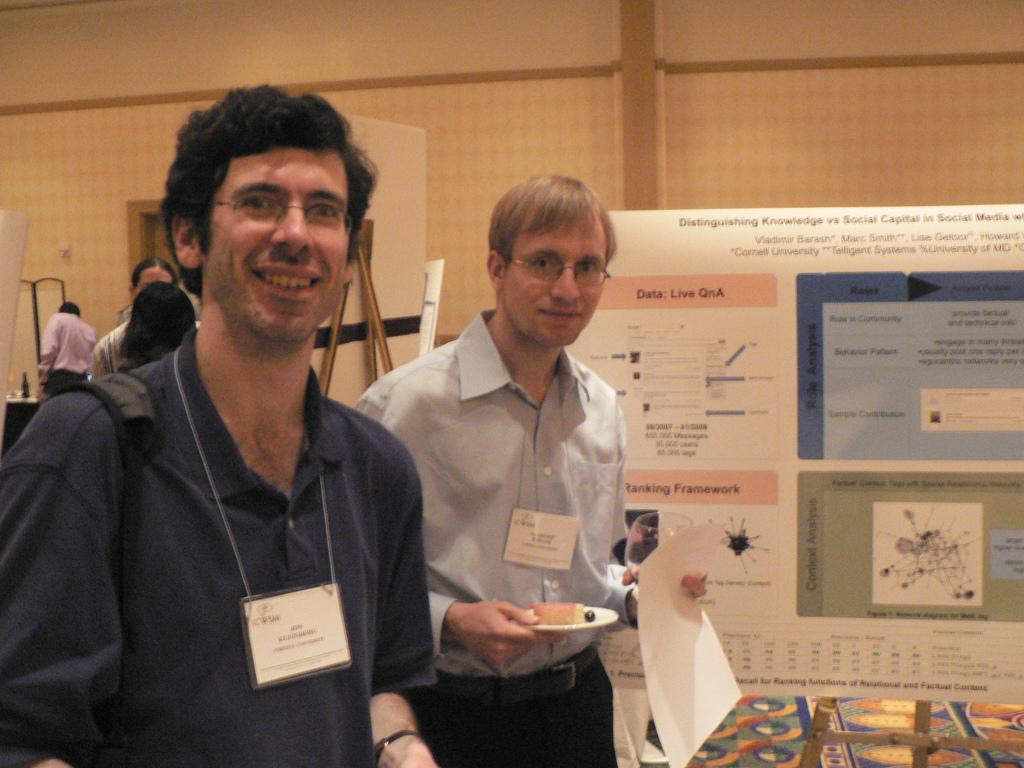What is the main subject in the foreground of the image? There is a group of people in the foreground of the image. What can be seen in the background of the image? There is a wall, a door, and a poster in the background of the image. Where is the image taken? The image is taken in a hall. What letter is written on the stem of the poster in the image? There is no letter written on the stem of the poster in the image, as the poster does not have a stem. 